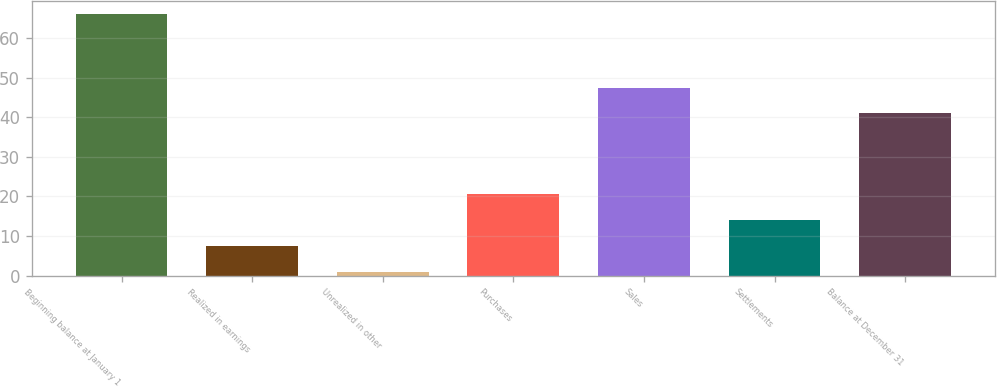Convert chart to OTSL. <chart><loc_0><loc_0><loc_500><loc_500><bar_chart><fcel>Beginning balance at January 1<fcel>Realized in earnings<fcel>Unrealized in other<fcel>Purchases<fcel>Sales<fcel>Settlements<fcel>Balance at December 31<nl><fcel>66<fcel>7.5<fcel>1<fcel>20.5<fcel>47.5<fcel>14<fcel>41<nl></chart> 